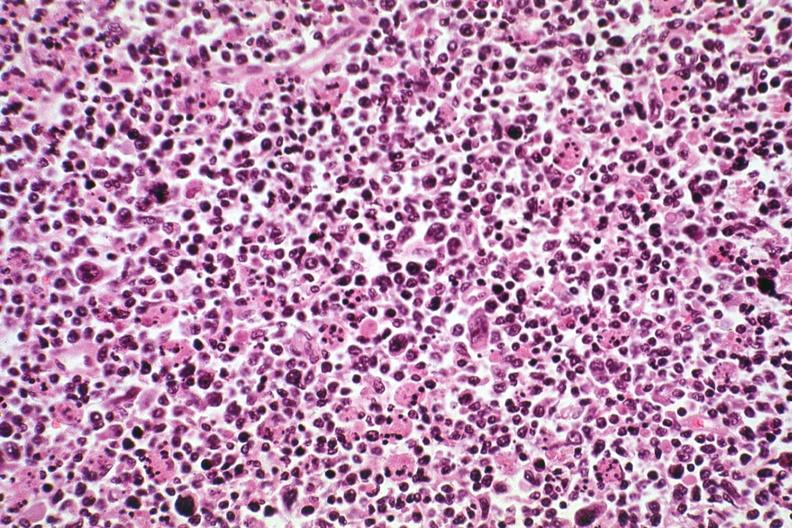what does this image show?
Answer the question using a single word or phrase. Pleomorphic see other slides case 